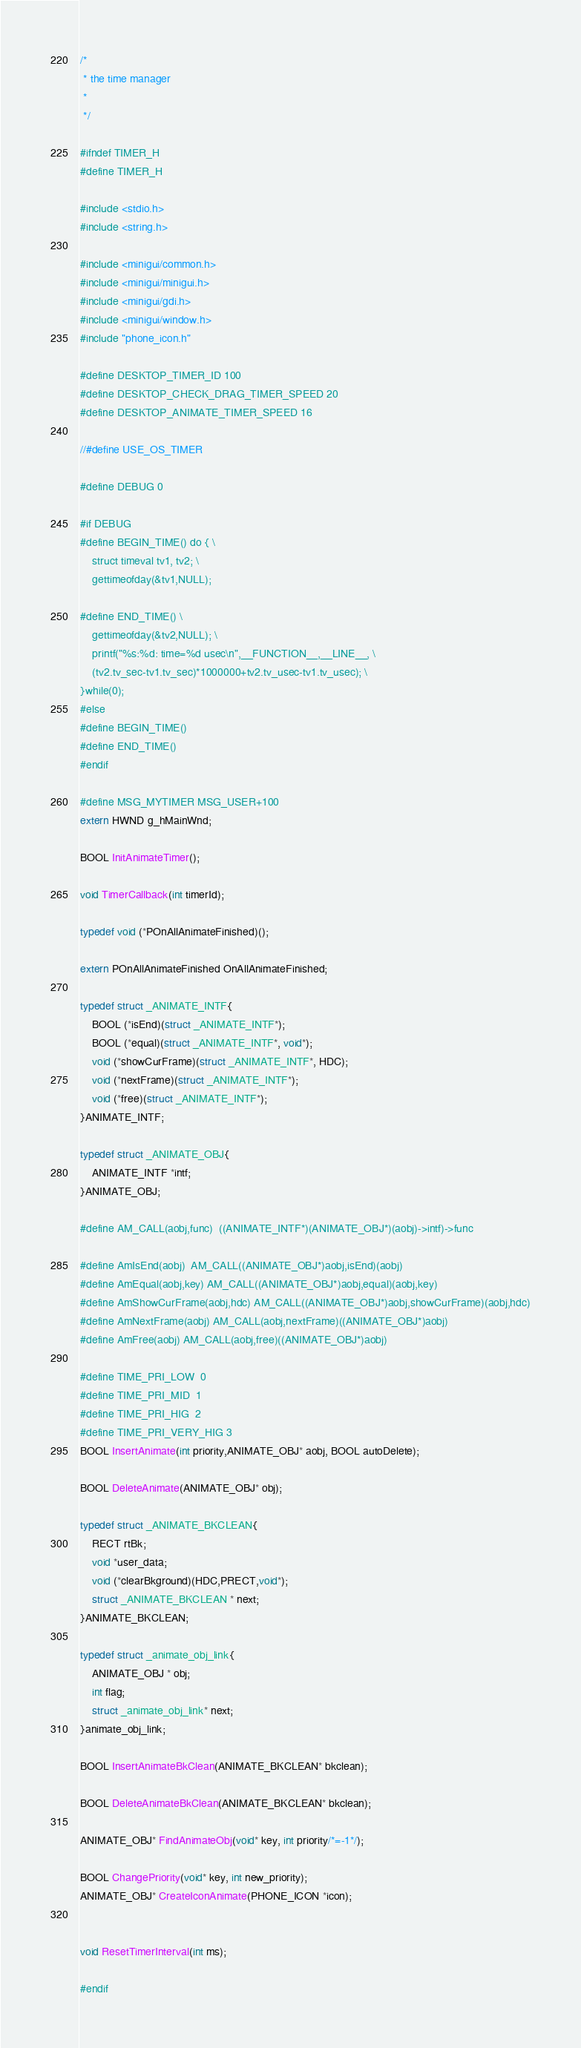Convert code to text. <code><loc_0><loc_0><loc_500><loc_500><_C_>/*
 * the time manager
 *
 */

#ifndef TIMER_H
#define TIMER_H

#include <stdio.h>
#include <string.h>

#include <minigui/common.h>
#include <minigui/minigui.h>
#include <minigui/gdi.h>
#include <minigui/window.h>
#include "phone_icon.h"

#define DESKTOP_TIMER_ID 100
#define DESKTOP_CHECK_DRAG_TIMER_SPEED 20
#define DESKTOP_ANIMATE_TIMER_SPEED 16 

//#define USE_OS_TIMER

#define DEBUG 0

#if DEBUG 
#define BEGIN_TIME() do { \
	struct timeval tv1, tv2; \
	gettimeofday(&tv1,NULL);

#define END_TIME() \
	gettimeofday(&tv2,NULL); \
	printf("%s:%d: time=%d usec\n",__FUNCTION__,__LINE__, \
	(tv2.tv_sec-tv1.tv_sec)*1000000+tv2.tv_usec-tv1.tv_usec); \
}while(0);
#else
#define BEGIN_TIME()
#define END_TIME()
#endif

#define MSG_MYTIMER MSG_USER+100
extern HWND g_hMainWnd;

BOOL InitAnimateTimer();

void TimerCallback(int timerId);

typedef void (*POnAllAnimateFinished)();

extern POnAllAnimateFinished OnAllAnimateFinished;

typedef struct _ANIMATE_INTF{
	BOOL (*isEnd)(struct _ANIMATE_INTF*);
	BOOL (*equal)(struct _ANIMATE_INTF*, void*);
	void (*showCurFrame)(struct _ANIMATE_INTF*, HDC);
	void (*nextFrame)(struct _ANIMATE_INTF*);
	void (*free)(struct _ANIMATE_INTF*);
}ANIMATE_INTF;

typedef struct _ANIMATE_OBJ{
	ANIMATE_INTF *intf;
}ANIMATE_OBJ;

#define AM_CALL(aobj,func)  ((ANIMATE_INTF*)(ANIMATE_OBJ*)(aobj)->intf)->func

#define AmIsEnd(aobj)  AM_CALL((ANIMATE_OBJ*)aobj,isEnd)(aobj)
#define AmEqual(aobj,key) AM_CALL((ANIMATE_OBJ*)aobj,equal)(aobj,key)
#define AmShowCurFrame(aobj,hdc) AM_CALL((ANIMATE_OBJ*)aobj,showCurFrame)(aobj,hdc)
#define AmNextFrame(aobj) AM_CALL(aobj,nextFrame)((ANIMATE_OBJ*)aobj)
#define AmFree(aobj) AM_CALL(aobj,free)((ANIMATE_OBJ*)aobj)

#define TIME_PRI_LOW  0
#define TIME_PRI_MID  1
#define TIME_PRI_HIG  2
#define TIME_PRI_VERY_HIG 3
BOOL InsertAnimate(int priority,ANIMATE_OBJ* aobj, BOOL autoDelete);

BOOL DeleteAnimate(ANIMATE_OBJ* obj);

typedef struct _ANIMATE_BKCLEAN{
	RECT rtBk;
	void *user_data;
	void (*clearBkground)(HDC,PRECT,void*);
	struct _ANIMATE_BKCLEAN * next;
}ANIMATE_BKCLEAN;

typedef struct _animate_obj_link{
	ANIMATE_OBJ * obj;
	int flag;
	struct _animate_obj_link* next;
}animate_obj_link;

BOOL InsertAnimateBkClean(ANIMATE_BKCLEAN* bkclean);

BOOL DeleteAnimateBkClean(ANIMATE_BKCLEAN* bkclean);

ANIMATE_OBJ* FindAnimateObj(void* key, int priority/*=-1*/);

BOOL ChangePriority(void* key, int new_priority);
ANIMATE_OBJ* CreateIconAnimate(PHONE_ICON *icon);


void ResetTimerInterval(int ms);

#endif
</code> 